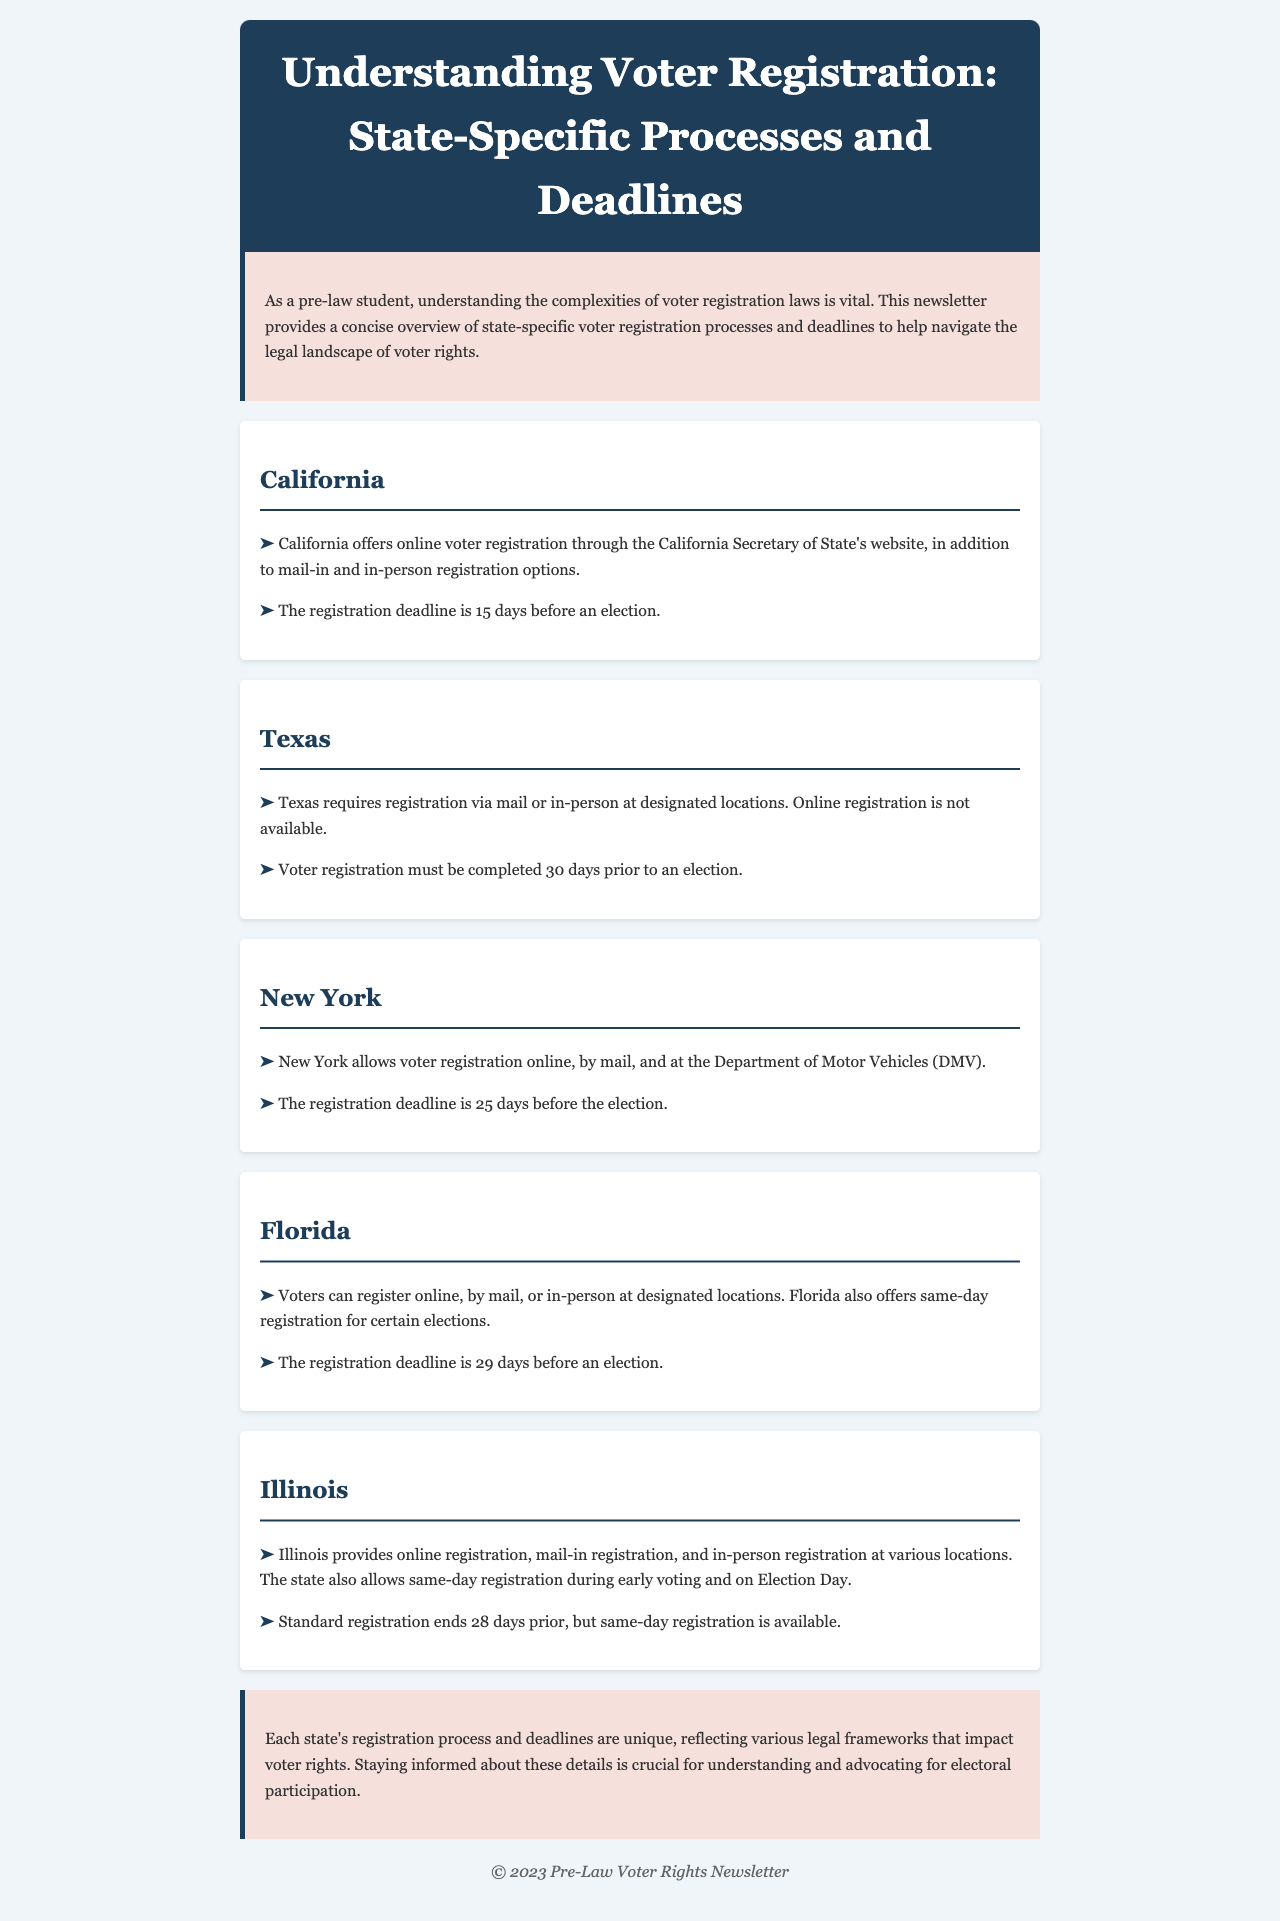what is the registration deadline in California? The registration deadline in California is stated clearly in the document.
Answer: 15 days before an election what registration methods are available in Texas? The document lists the registration methods for Texas, indicating that online registration is not an option.
Answer: Mail or in-person what is the registration deadline in New York? The registration deadline in New York is provided in the document and gives a specific period.
Answer: 25 days before the election which state offers same-day registration? The document mentions that multiple states provide same-day registration, but specifies Illinois.
Answer: Illinois how many days before an election does Florida require registration to be completed? This information can be found in the deadline section for Florida.
Answer: 29 days what is the unique feature offered by Florida in its voter registration process? The document highlights a special condition present in Florida's voter registration process.
Answer: Same-day registration which state does not offer online voter registration? The document specifies which states do not provide this option in their registration process.
Answer: Texas name a state that allows voter registration at the DMV. The document explicitly states one state that offers this registration option, enabling quick identification.
Answer: New York how many days prior does Illinois allow for standard registration to end? The standard registration timing is detailed in the Illinois section of the document.
Answer: 28 days 